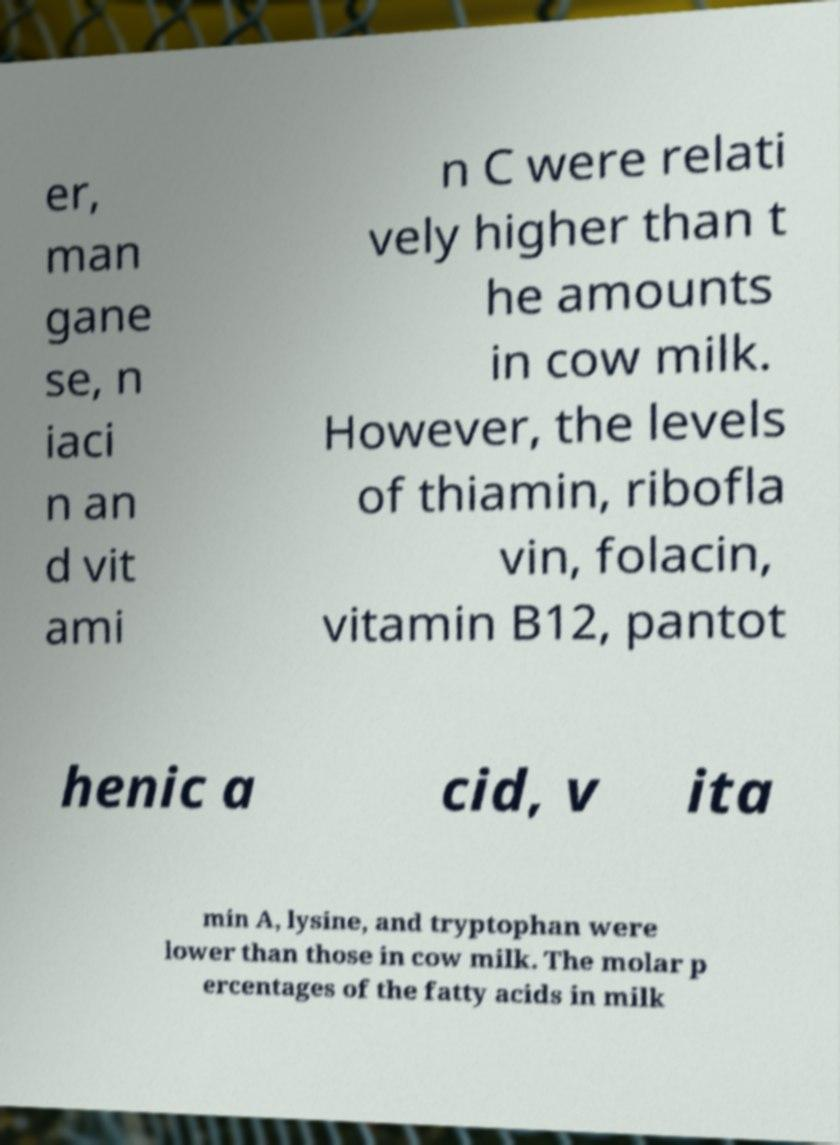Can you read and provide the text displayed in the image?This photo seems to have some interesting text. Can you extract and type it out for me? er, man gane se, n iaci n an d vit ami n C were relati vely higher than t he amounts in cow milk. However, the levels of thiamin, ribofla vin, folacin, vitamin B12, pantot henic a cid, v ita min A, lysine, and tryptophan were lower than those in cow milk. The molar p ercentages of the fatty acids in milk 